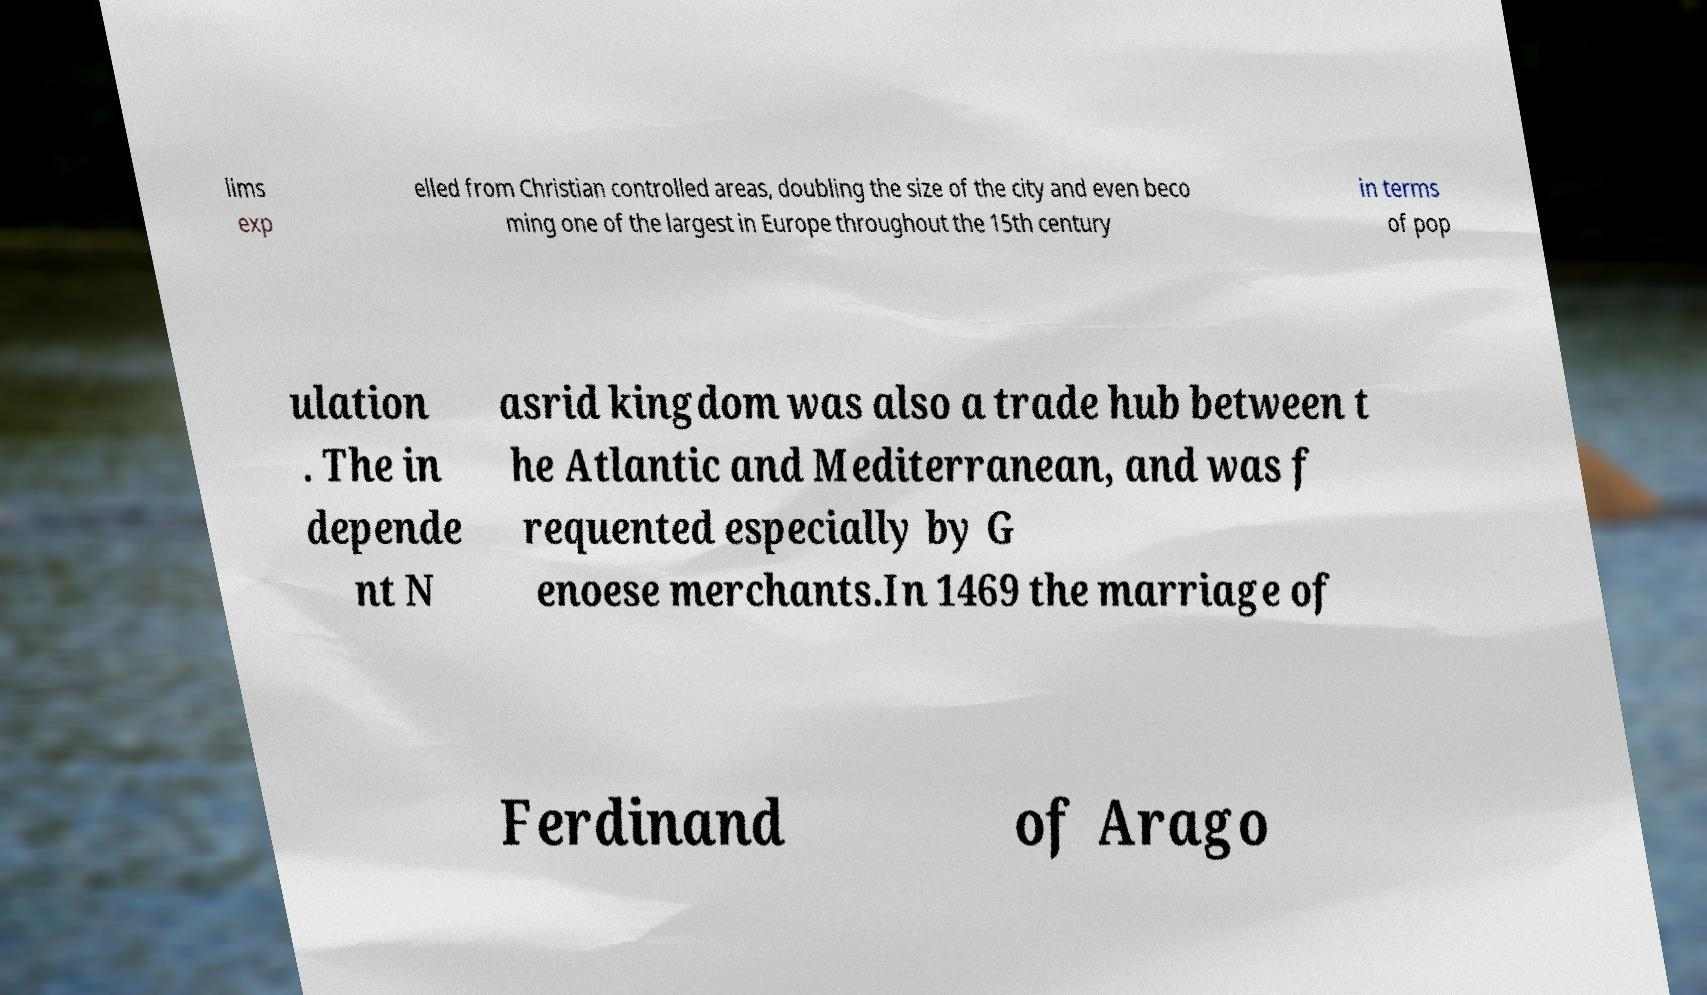Please identify and transcribe the text found in this image. lims exp elled from Christian controlled areas, doubling the size of the city and even beco ming one of the largest in Europe throughout the 15th century in terms of pop ulation . The in depende nt N asrid kingdom was also a trade hub between t he Atlantic and Mediterranean, and was f requented especially by G enoese merchants.In 1469 the marriage of Ferdinand of Arago 